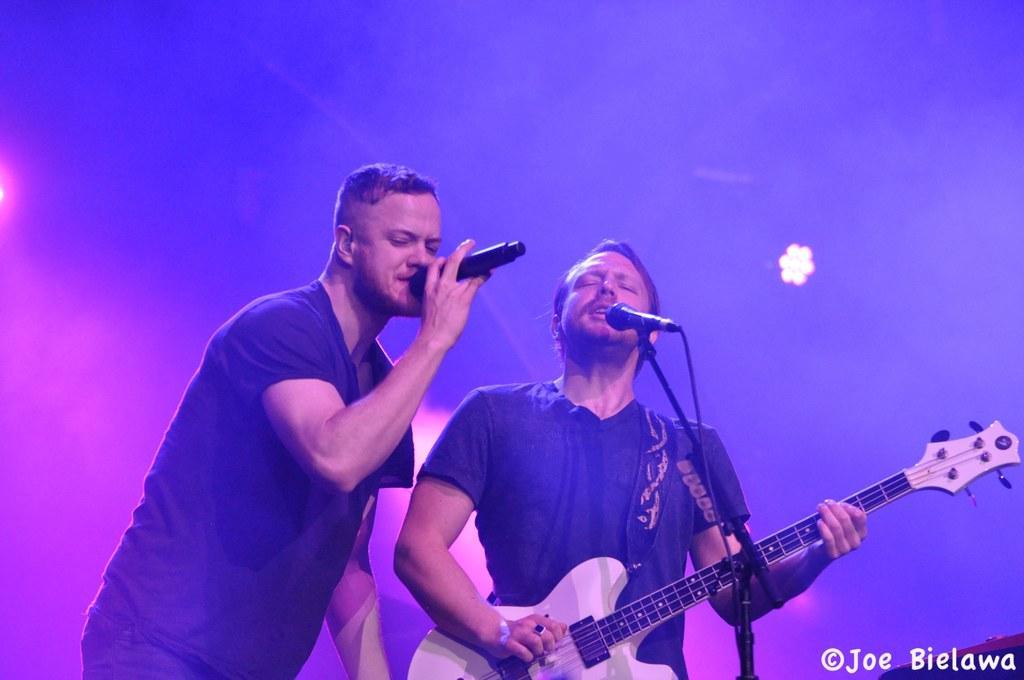Can you describe this image briefly? In the picture there are two people, left side of the picture one person is wearing a black t-shirt and holding a microphone and the corner of the picture another person is wearing black t-shirt and wearing a guitar and playing it and singing in the microphone and the background is covered with a smoke and lights. 